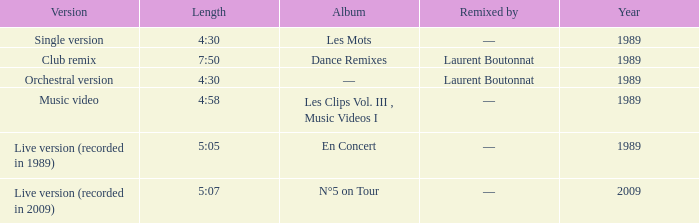Album of les mots had what lowest year? 1989.0. 